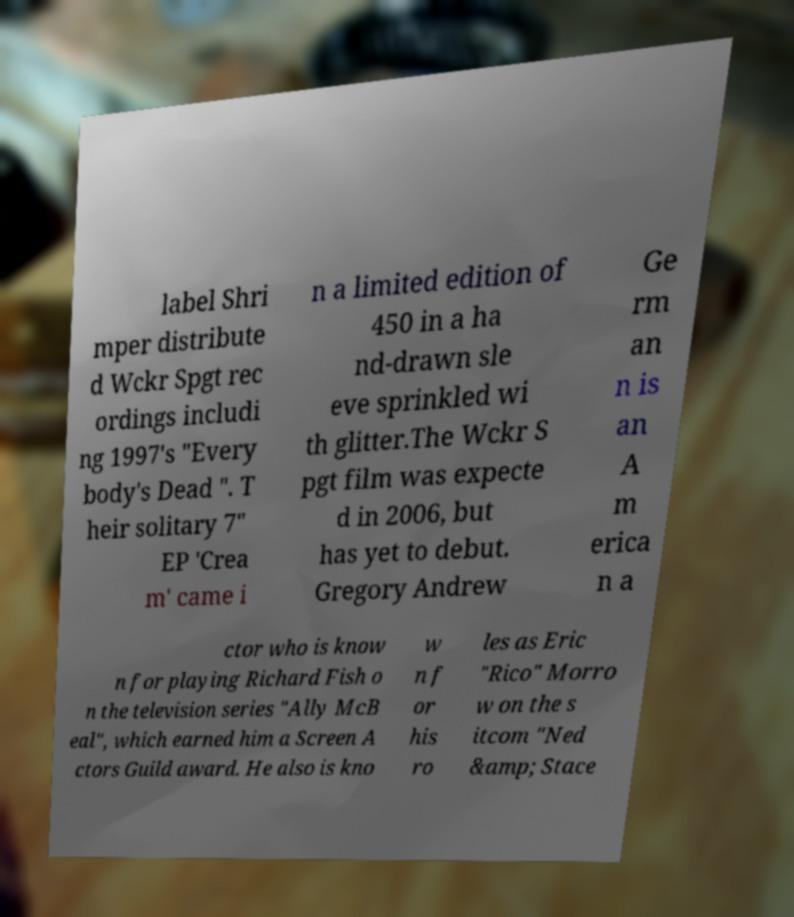I need the written content from this picture converted into text. Can you do that? label Shri mper distribute d Wckr Spgt rec ordings includi ng 1997's "Every body's Dead ". T heir solitary 7" EP 'Crea m' came i n a limited edition of 450 in a ha nd-drawn sle eve sprinkled wi th glitter.The Wckr S pgt film was expecte d in 2006, but has yet to debut. Gregory Andrew Ge rm an n is an A m erica n a ctor who is know n for playing Richard Fish o n the television series "Ally McB eal", which earned him a Screen A ctors Guild award. He also is kno w n f or his ro les as Eric "Rico" Morro w on the s itcom "Ned &amp; Stace 